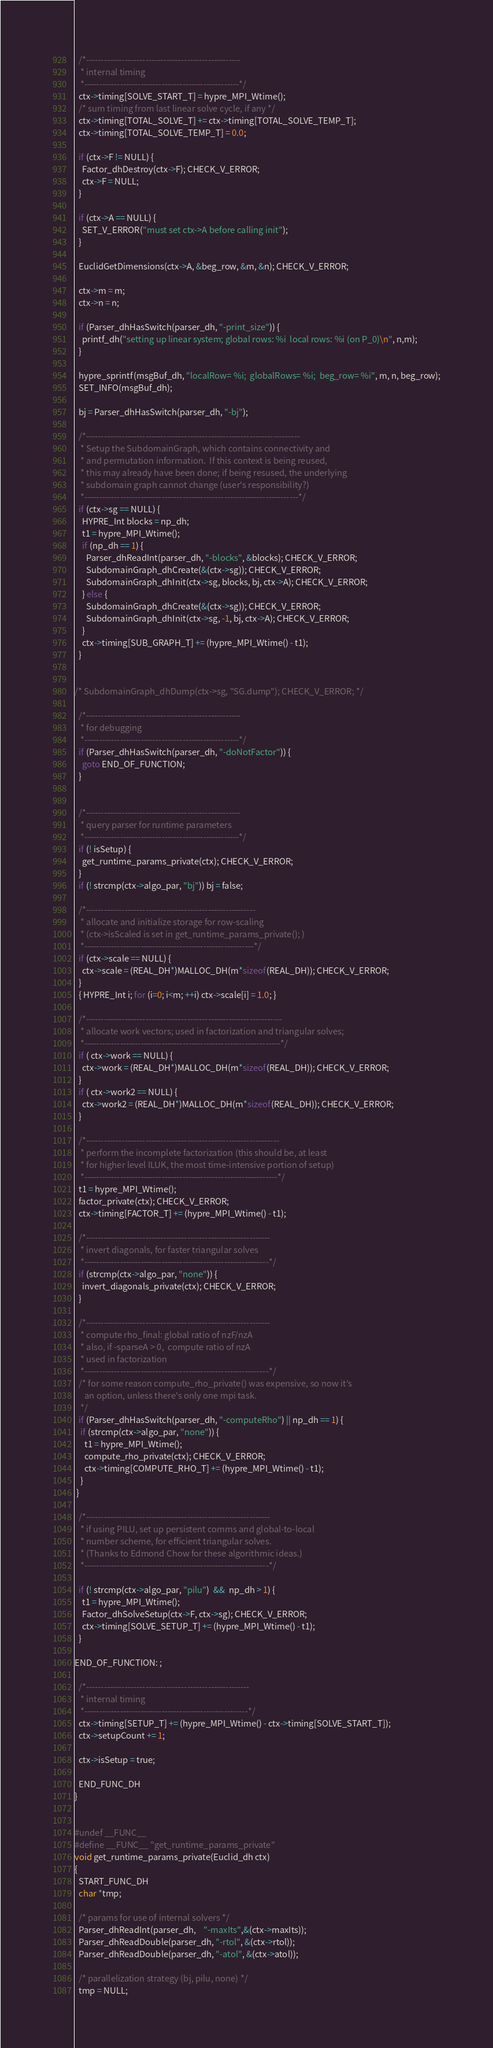<code> <loc_0><loc_0><loc_500><loc_500><_C_>
  /*----------------------------------------------------
   * internal timing
   *----------------------------------------------------*/
  ctx->timing[SOLVE_START_T] = hypre_MPI_Wtime();
  /* sum timing from last linear solve cycle, if any */
  ctx->timing[TOTAL_SOLVE_T] += ctx->timing[TOTAL_SOLVE_TEMP_T];
  ctx->timing[TOTAL_SOLVE_TEMP_T] = 0.0;

  if (ctx->F != NULL) {
    Factor_dhDestroy(ctx->F); CHECK_V_ERROR;
    ctx->F = NULL;
  }

  if (ctx->A == NULL) {
    SET_V_ERROR("must set ctx->A before calling init");
  }

  EuclidGetDimensions(ctx->A, &beg_row, &m, &n); CHECK_V_ERROR;

  ctx->m = m;
  ctx->n = n;

  if (Parser_dhHasSwitch(parser_dh, "-print_size")) {
    printf_dh("setting up linear system; global rows: %i  local rows: %i (on P_0)\n", n,m);
  }

  hypre_sprintf(msgBuf_dh, "localRow= %i;  globalRows= %i;  beg_row= %i", m, n, beg_row);
  SET_INFO(msgBuf_dh);

  bj = Parser_dhHasSwitch(parser_dh, "-bj");

  /*------------------------------------------------------------------------
   * Setup the SubdomainGraph, which contains connectivity and
   * and permutation information.  If this context is being reused,
   * this may already have been done; if being resused, the underlying
   * subdomain graph cannot change (user's responsibility?)
   *------------------------------------------------------------------------*/
  if (ctx->sg == NULL) {
    HYPRE_Int blocks = np_dh;
    t1 = hypre_MPI_Wtime();
    if (np_dh == 1) {
      Parser_dhReadInt(parser_dh, "-blocks", &blocks); CHECK_V_ERROR;
      SubdomainGraph_dhCreate(&(ctx->sg)); CHECK_V_ERROR;
      SubdomainGraph_dhInit(ctx->sg, blocks, bj, ctx->A); CHECK_V_ERROR;
    } else {
      SubdomainGraph_dhCreate(&(ctx->sg)); CHECK_V_ERROR;
      SubdomainGraph_dhInit(ctx->sg, -1, bj, ctx->A); CHECK_V_ERROR;
    }
    ctx->timing[SUB_GRAPH_T] += (hypre_MPI_Wtime() - t1);
  }


/* SubdomainGraph_dhDump(ctx->sg, "SG.dump"); CHECK_V_ERROR; */

  /*----------------------------------------------------
   * for debugging
   *----------------------------------------------------*/
  if (Parser_dhHasSwitch(parser_dh, "-doNotFactor")) {
    goto END_OF_FUNCTION;
  }


  /*----------------------------------------------------
   * query parser for runtime parameters
   *----------------------------------------------------*/
  if (! isSetup) {
    get_runtime_params_private(ctx); CHECK_V_ERROR;
  }
  if (! strcmp(ctx->algo_par, "bj")) bj = false;

  /*---------------------------------------------------------
   * allocate and initialize storage for row-scaling
   * (ctx->isScaled is set in get_runtime_params_private(); )
   *---------------------------------------------------------*/
  if (ctx->scale == NULL) {
    ctx->scale = (REAL_DH*)MALLOC_DH(m*sizeof(REAL_DH)); CHECK_V_ERROR;
  }
  { HYPRE_Int i; for (i=0; i<m; ++i) ctx->scale[i] = 1.0; }

  /*------------------------------------------------------------------
   * allocate work vectors; used in factorization and triangular solves;
   *------------------------------------------------------------------*/
  if ( ctx->work == NULL) {
    ctx->work = (REAL_DH*)MALLOC_DH(m*sizeof(REAL_DH)); CHECK_V_ERROR;
  }
  if ( ctx->work2 == NULL) {
    ctx->work2 = (REAL_DH*)MALLOC_DH(m*sizeof(REAL_DH)); CHECK_V_ERROR;
  }

  /*-----------------------------------------------------------------
   * perform the incomplete factorization (this should be, at least
   * for higher level ILUK, the most time-intensive portion of setup)
   *-----------------------------------------------------------------*/
  t1 = hypre_MPI_Wtime();
  factor_private(ctx); CHECK_V_ERROR;
  ctx->timing[FACTOR_T] += (hypre_MPI_Wtime() - t1);

  /*--------------------------------------------------------------
   * invert diagonals, for faster triangular solves
   *--------------------------------------------------------------*/
  if (strcmp(ctx->algo_par, "none")) {
    invert_diagonals_private(ctx); CHECK_V_ERROR;
  }

  /*--------------------------------------------------------------
   * compute rho_final: global ratio of nzF/nzA
   * also, if -sparseA > 0,  compute ratio of nzA
   * used in factorization
   *--------------------------------------------------------------*/
  /* for some reason compute_rho_private() was expensive, so now it's
     an option, unless there's only one mpi task.
   */
  if (Parser_dhHasSwitch(parser_dh, "-computeRho") || np_dh == 1) {
   if (strcmp(ctx->algo_par, "none")) {
     t1 = hypre_MPI_Wtime();
     compute_rho_private(ctx); CHECK_V_ERROR;
     ctx->timing[COMPUTE_RHO_T] += (hypre_MPI_Wtime() - t1);
   }
 }

  /*--------------------------------------------------------------
   * if using PILU, set up persistent comms and global-to-local
   * number scheme, for efficient triangular solves.
   * (Thanks to Edmond Chow for these algorithmic ideas.)
   *--------------------------------------------------------------*/

  if (! strcmp(ctx->algo_par, "pilu")  &&  np_dh > 1) {
    t1 = hypre_MPI_Wtime();
    Factor_dhSolveSetup(ctx->F, ctx->sg); CHECK_V_ERROR;
    ctx->timing[SOLVE_SETUP_T] += (hypre_MPI_Wtime() - t1);
  }

END_OF_FUNCTION: ;

  /*-------------------------------------------------------
   * internal timing
   *-------------------------------------------------------*/
  ctx->timing[SETUP_T] += (hypre_MPI_Wtime() - ctx->timing[SOLVE_START_T]);
  ctx->setupCount += 1;

  ctx->isSetup = true;

  END_FUNC_DH
}


#undef __FUNC__
#define __FUNC__ "get_runtime_params_private"
void get_runtime_params_private(Euclid_dh ctx)
{
  START_FUNC_DH
  char *tmp;

  /* params for use of internal solvers */
  Parser_dhReadInt(parser_dh,    "-maxIts",&(ctx->maxIts));
  Parser_dhReadDouble(parser_dh, "-rtol", &(ctx->rtol));
  Parser_dhReadDouble(parser_dh, "-atol", &(ctx->atol));

  /* parallelization strategy (bj, pilu, none) */
  tmp = NULL;</code> 